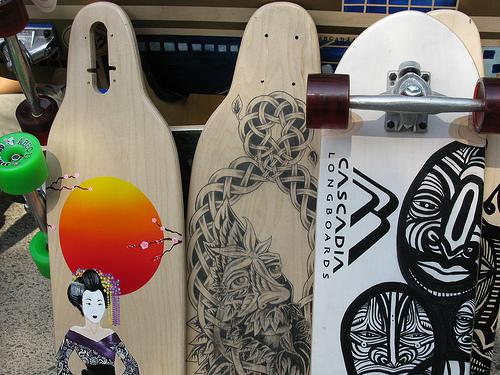Question: what is the brand of the skateboard with wheels?
Choices:
A. Doom.
B. Longboard.
C. 420.
D. Cascadia Longboards.
Answer with the letter. Answer: D Question: what are the skateboards made of?
Choices:
A. Wood.
B. Metal.
C. Plastic.
D. Ink.
Answer with the letter. Answer: A Question: what color is the sun on the design?
Choices:
A. Yellow.
B. Orange.
C. Red.
D. Green.
Answer with the letter. Answer: B 